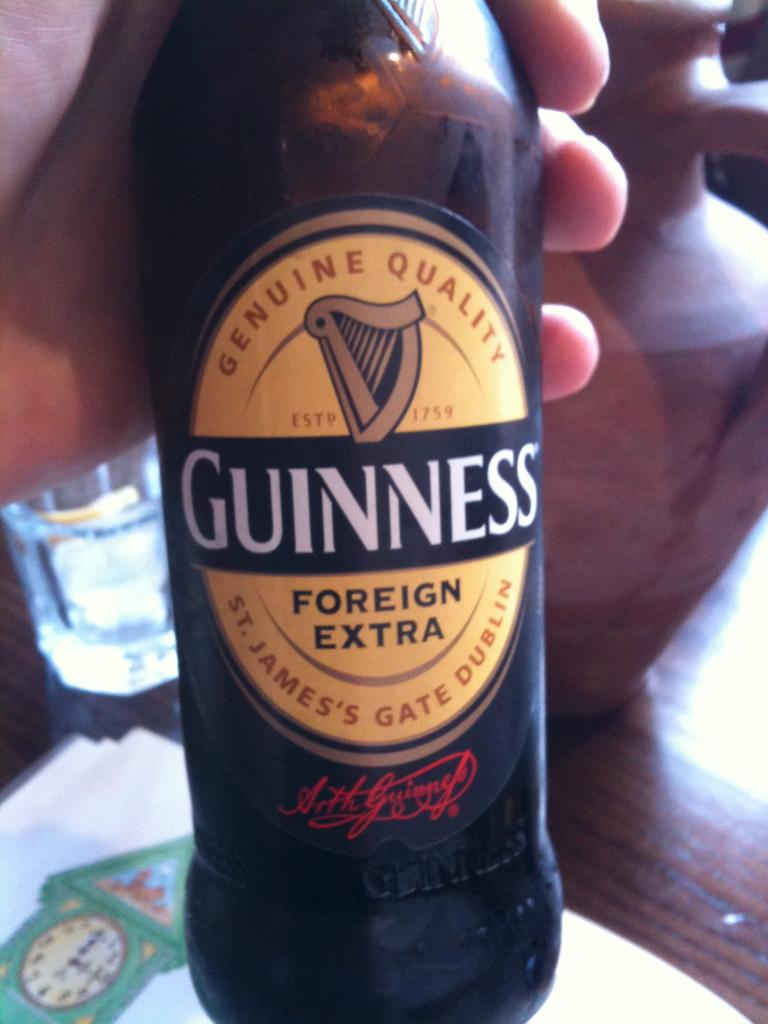<image>
Provide a brief description of the given image. A bottle of Guinness says "genuine quality" on the label. 